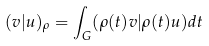Convert formula to latex. <formula><loc_0><loc_0><loc_500><loc_500>( v | u ) _ { \rho } = \int _ { G } ( \rho ( t ) v | \rho ( t ) u ) d t</formula> 